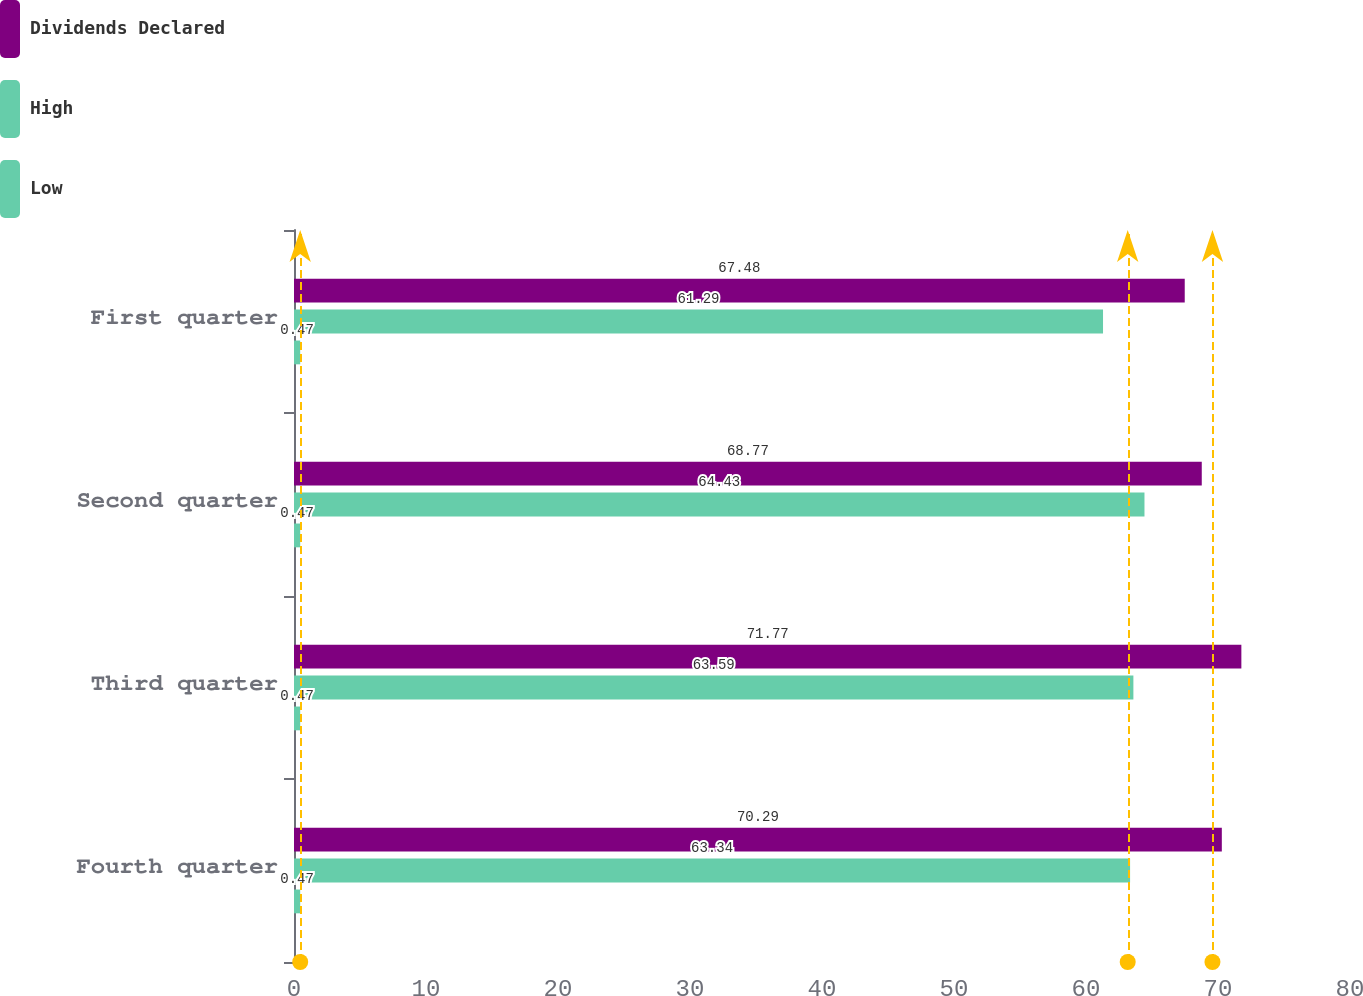Convert chart. <chart><loc_0><loc_0><loc_500><loc_500><stacked_bar_chart><ecel><fcel>Fourth quarter<fcel>Third quarter<fcel>Second quarter<fcel>First quarter<nl><fcel>Dividends Declared<fcel>70.29<fcel>71.77<fcel>68.77<fcel>67.48<nl><fcel>High<fcel>63.34<fcel>63.59<fcel>64.43<fcel>61.29<nl><fcel>Low<fcel>0.47<fcel>0.47<fcel>0.47<fcel>0.47<nl></chart> 